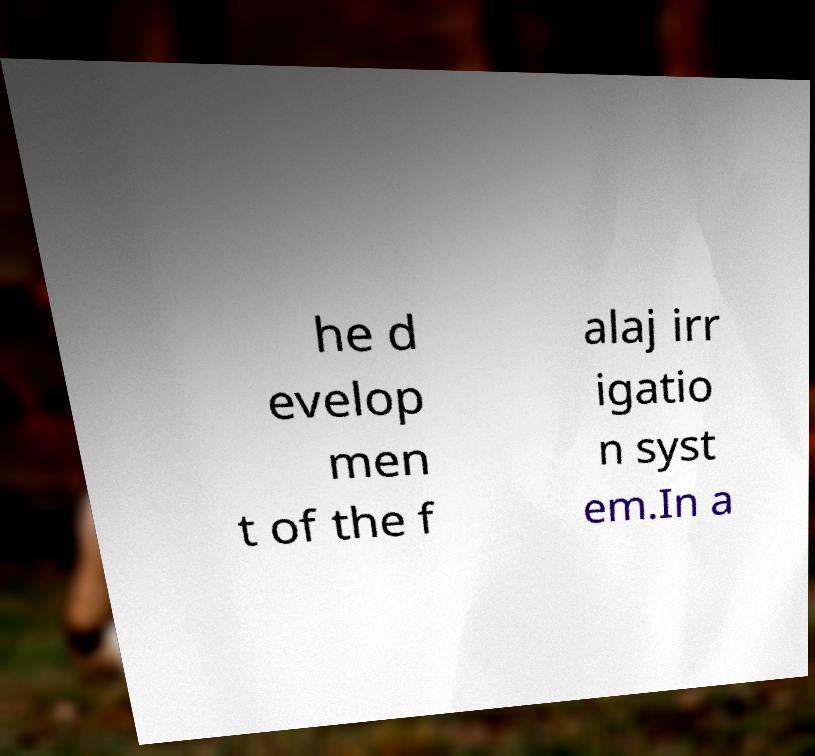There's text embedded in this image that I need extracted. Can you transcribe it verbatim? he d evelop men t of the f alaj irr igatio n syst em.In a 